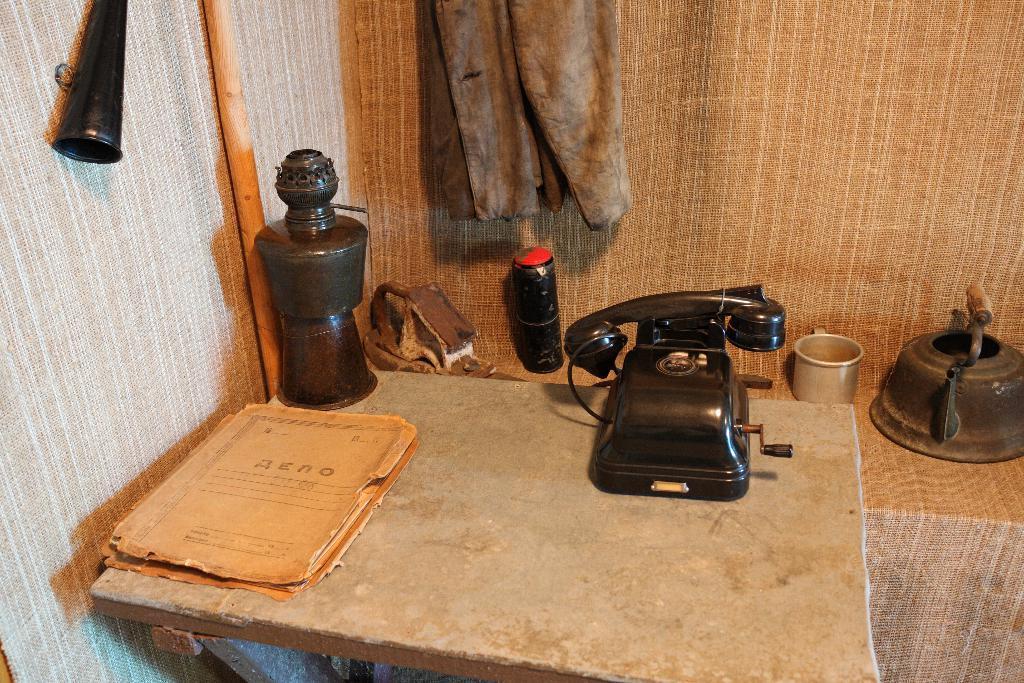Describe this image in one or two sentences. In this image, we can see some objects. There is a table at the bottom of the image contains telephone, oil lamp and file. There is a cloth at the top of the image. There is a pipe in the middle of the image. 